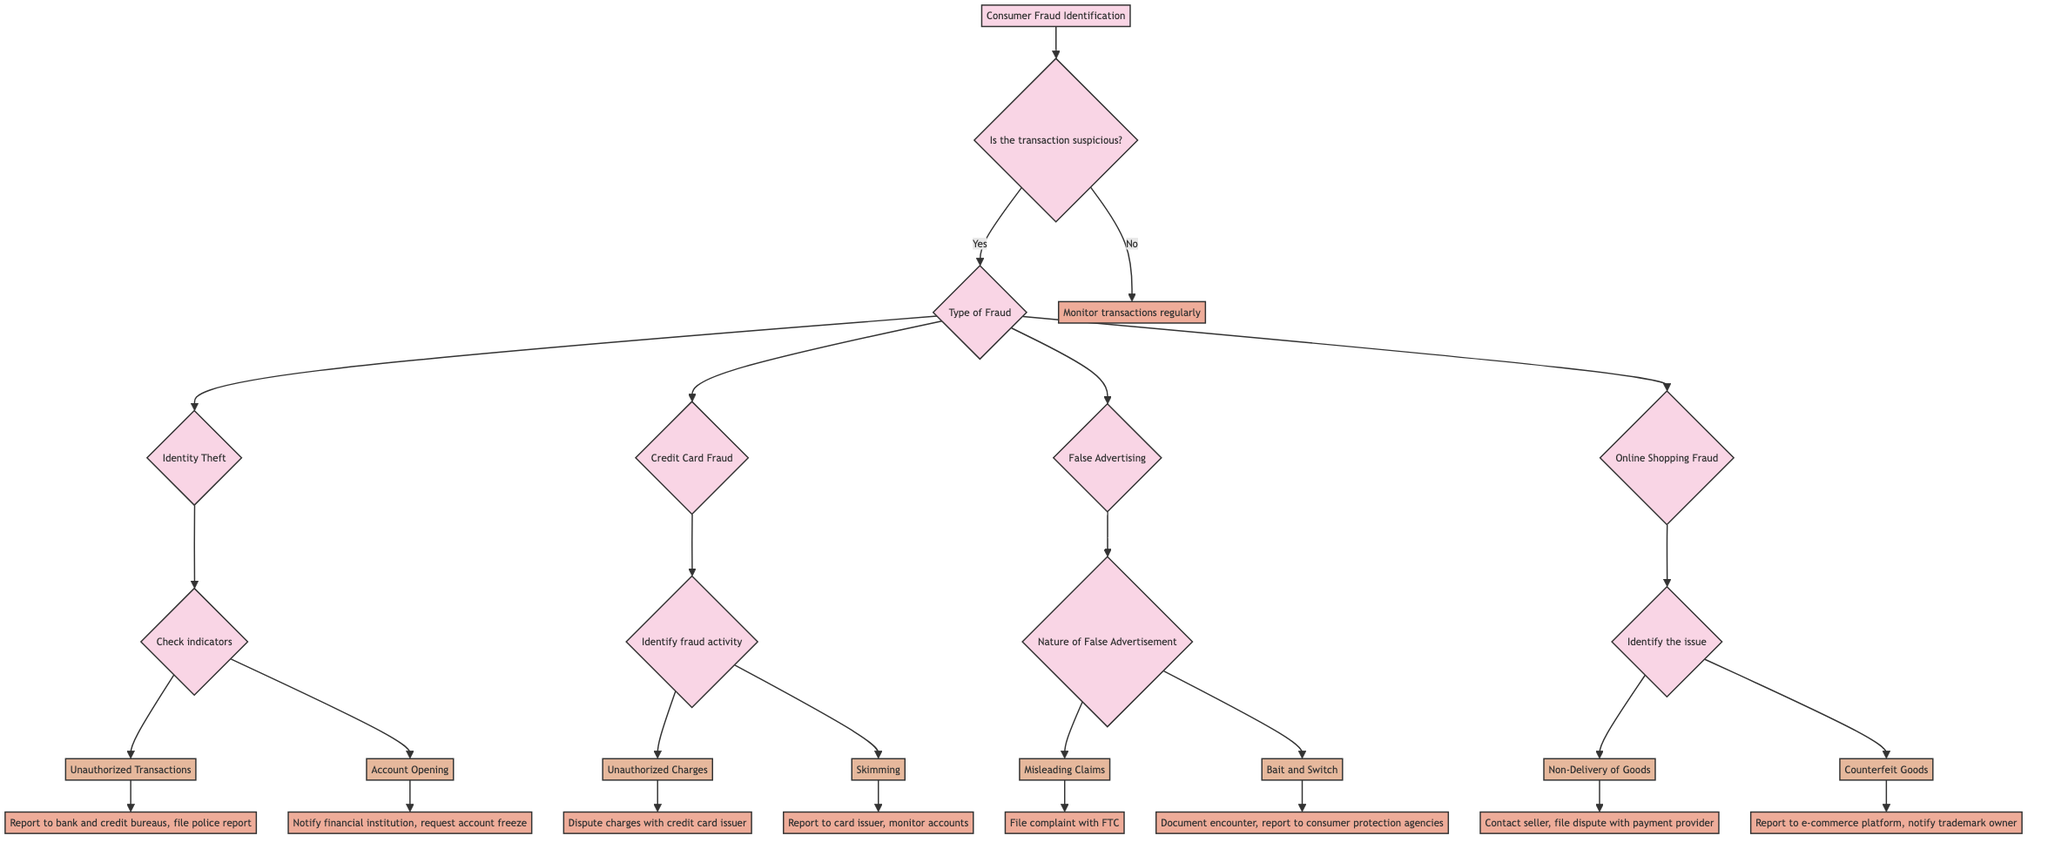Is there a node for "Identity Theft"? Yes, there is a node labeled "Identity Theft" under the "Type of Fraud" decision point.
Answer: Yes What action is suggested for "Unauthorized Transactions"? "Unauthorized Transactions" is a branch under "Identity Theft" that leads to the action of reporting to the bank and credit bureaus and filing a police report.
Answer: Report to bank and credit bureaus, file a police report How many types of fraud are identified in the decision tree? The diagram specifically identifies four types of fraud: Identity Theft, Credit Card Fraud, False Advertising, and Online Shopping Fraud.
Answer: Four What happens if the transaction is not suspicious? If the transaction is not suspicious, the action is to monitor transactions regularly.
Answer: Monitor transactions regularly What is the action to take after being a victim of "Counterfeit Goods"? The "Counterfeit Goods" branch is under "Online Shopping Fraud" and leads to the action of reporting to the e-commerce platform and notifying the trademark owner.
Answer: Report to e-commerce platform, notify the trademark owner Which type of fraud requires filing a complaint with the Federal Trade Commission? The type of fraud that requires this action is "False Advertising," specifically under the branch "Misleading Claims."
Answer: Misleading Claims If a transaction is suspicious, what is the next question asked in the decision tree? The next question asked after a transaction is identified as suspicious is "Type of Fraud."
Answer: Type of Fraud What are the two factors considered in "Credit Card Fraud"? The two factors considered are "Unauthorized Charges" and "Skimming," both leading to different actions.
Answer: Unauthorized Charges and Skimming 